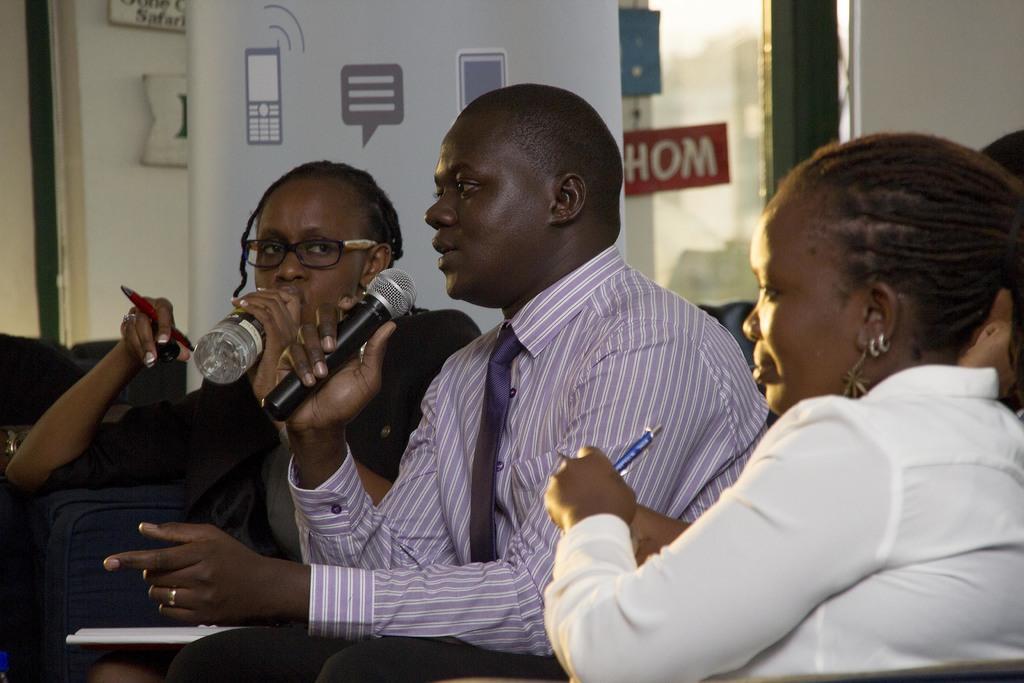In one or two sentences, can you explain what this image depicts? As we can see in the image there is a wall, banner, few people sitting over here. The women who is sitting in the left side is drinking water in water bottle. The man in the middle is holding a mic. 